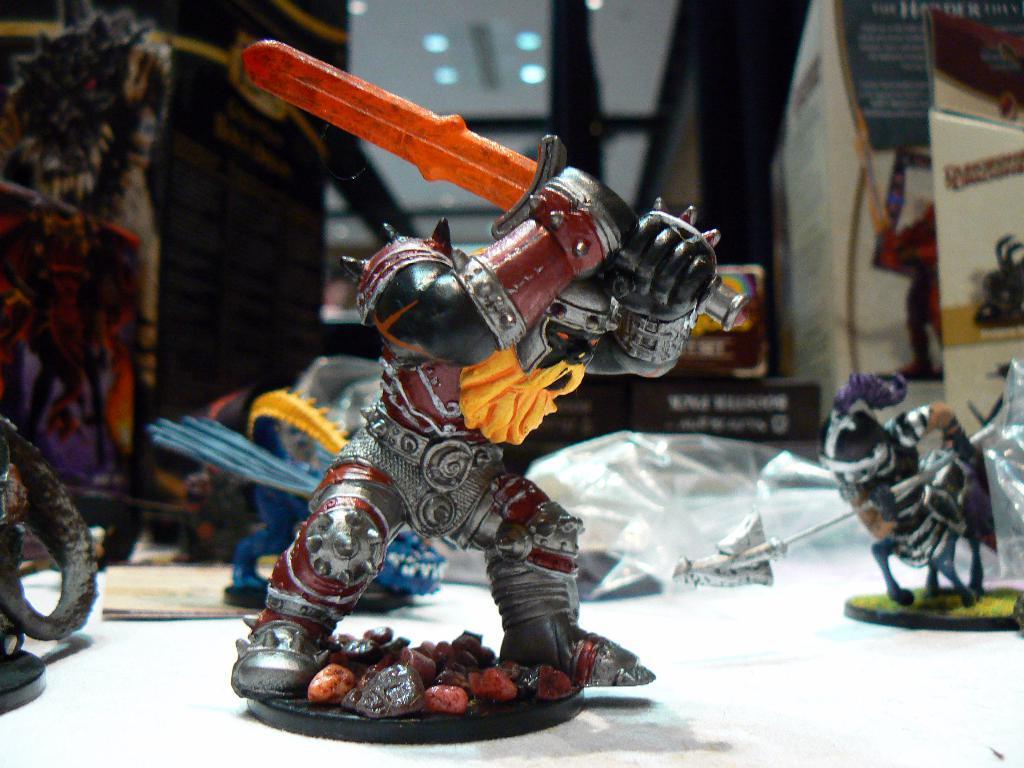Can you describe this image briefly? In the image there is a toy of a soldier with sword in its hand and it there are few other toys along with covers and some articles. 